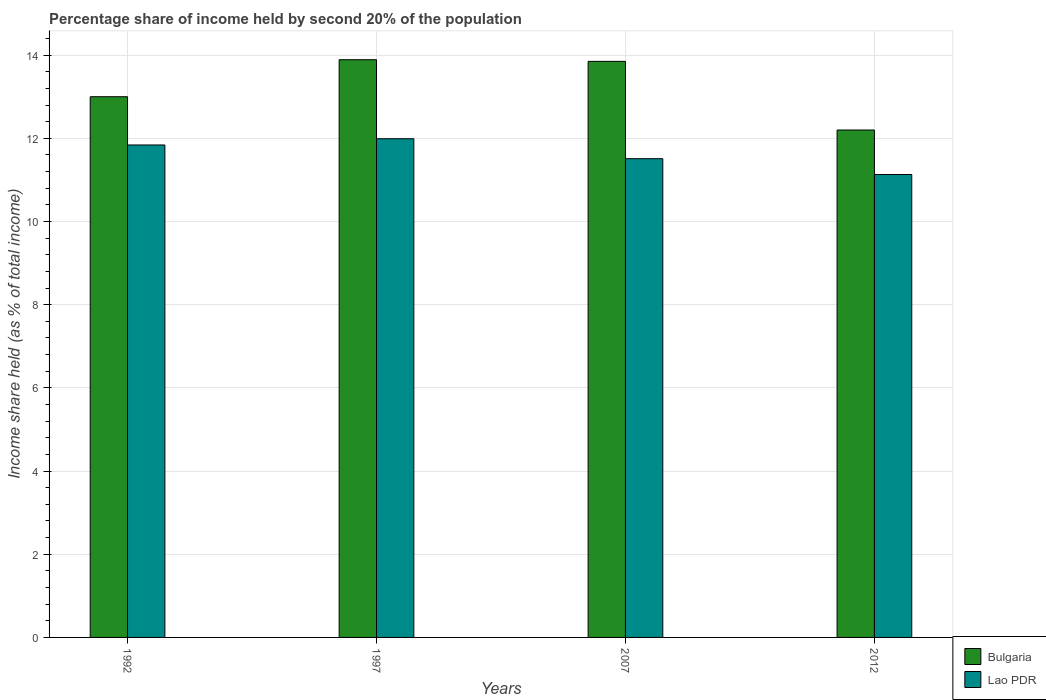How many different coloured bars are there?
Give a very brief answer. 2. Are the number of bars on each tick of the X-axis equal?
Provide a short and direct response. Yes. How many bars are there on the 2nd tick from the left?
Ensure brevity in your answer.  2. How many bars are there on the 2nd tick from the right?
Provide a short and direct response. 2. In how many cases, is the number of bars for a given year not equal to the number of legend labels?
Offer a terse response. 0. What is the share of income held by second 20% of the population in Lao PDR in 2012?
Offer a terse response. 11.13. Across all years, what is the maximum share of income held by second 20% of the population in Bulgaria?
Offer a terse response. 13.89. Across all years, what is the minimum share of income held by second 20% of the population in Lao PDR?
Provide a succinct answer. 11.13. In which year was the share of income held by second 20% of the population in Bulgaria maximum?
Give a very brief answer. 1997. In which year was the share of income held by second 20% of the population in Bulgaria minimum?
Provide a succinct answer. 2012. What is the total share of income held by second 20% of the population in Lao PDR in the graph?
Ensure brevity in your answer.  46.47. What is the difference between the share of income held by second 20% of the population in Lao PDR in 1997 and that in 2007?
Offer a terse response. 0.48. What is the difference between the share of income held by second 20% of the population in Lao PDR in 2007 and the share of income held by second 20% of the population in Bulgaria in 2012?
Offer a very short reply. -0.69. What is the average share of income held by second 20% of the population in Bulgaria per year?
Offer a very short reply. 13.23. In the year 1992, what is the difference between the share of income held by second 20% of the population in Bulgaria and share of income held by second 20% of the population in Lao PDR?
Your answer should be very brief. 1.16. In how many years, is the share of income held by second 20% of the population in Bulgaria greater than 4 %?
Your answer should be very brief. 4. What is the ratio of the share of income held by second 20% of the population in Lao PDR in 1997 to that in 2012?
Make the answer very short. 1.08. Is the difference between the share of income held by second 20% of the population in Bulgaria in 1992 and 2007 greater than the difference between the share of income held by second 20% of the population in Lao PDR in 1992 and 2007?
Provide a succinct answer. No. What is the difference between the highest and the second highest share of income held by second 20% of the population in Lao PDR?
Keep it short and to the point. 0.15. What is the difference between the highest and the lowest share of income held by second 20% of the population in Lao PDR?
Provide a succinct answer. 0.86. Is the sum of the share of income held by second 20% of the population in Lao PDR in 1997 and 2012 greater than the maximum share of income held by second 20% of the population in Bulgaria across all years?
Keep it short and to the point. Yes. What does the 2nd bar from the left in 1997 represents?
Your answer should be compact. Lao PDR. What does the 2nd bar from the right in 2007 represents?
Provide a succinct answer. Bulgaria. What is the difference between two consecutive major ticks on the Y-axis?
Offer a terse response. 2. Are the values on the major ticks of Y-axis written in scientific E-notation?
Provide a short and direct response. No. Does the graph contain grids?
Ensure brevity in your answer.  Yes. Where does the legend appear in the graph?
Your answer should be compact. Bottom right. How are the legend labels stacked?
Make the answer very short. Vertical. What is the title of the graph?
Keep it short and to the point. Percentage share of income held by second 20% of the population. What is the label or title of the X-axis?
Your answer should be compact. Years. What is the label or title of the Y-axis?
Ensure brevity in your answer.  Income share held (as % of total income). What is the Income share held (as % of total income) of Lao PDR in 1992?
Offer a terse response. 11.84. What is the Income share held (as % of total income) in Bulgaria in 1997?
Keep it short and to the point. 13.89. What is the Income share held (as % of total income) in Lao PDR in 1997?
Offer a very short reply. 11.99. What is the Income share held (as % of total income) of Bulgaria in 2007?
Provide a succinct answer. 13.85. What is the Income share held (as % of total income) in Lao PDR in 2007?
Offer a very short reply. 11.51. What is the Income share held (as % of total income) of Bulgaria in 2012?
Your response must be concise. 12.2. What is the Income share held (as % of total income) in Lao PDR in 2012?
Offer a terse response. 11.13. Across all years, what is the maximum Income share held (as % of total income) in Bulgaria?
Offer a terse response. 13.89. Across all years, what is the maximum Income share held (as % of total income) in Lao PDR?
Ensure brevity in your answer.  11.99. Across all years, what is the minimum Income share held (as % of total income) of Lao PDR?
Ensure brevity in your answer.  11.13. What is the total Income share held (as % of total income) of Bulgaria in the graph?
Make the answer very short. 52.94. What is the total Income share held (as % of total income) of Lao PDR in the graph?
Offer a terse response. 46.47. What is the difference between the Income share held (as % of total income) of Bulgaria in 1992 and that in 1997?
Keep it short and to the point. -0.89. What is the difference between the Income share held (as % of total income) in Bulgaria in 1992 and that in 2007?
Your answer should be very brief. -0.85. What is the difference between the Income share held (as % of total income) of Lao PDR in 1992 and that in 2007?
Provide a succinct answer. 0.33. What is the difference between the Income share held (as % of total income) of Lao PDR in 1992 and that in 2012?
Give a very brief answer. 0.71. What is the difference between the Income share held (as % of total income) in Bulgaria in 1997 and that in 2007?
Ensure brevity in your answer.  0.04. What is the difference between the Income share held (as % of total income) in Lao PDR in 1997 and that in 2007?
Your answer should be very brief. 0.48. What is the difference between the Income share held (as % of total income) of Bulgaria in 1997 and that in 2012?
Your answer should be compact. 1.69. What is the difference between the Income share held (as % of total income) of Lao PDR in 1997 and that in 2012?
Your answer should be compact. 0.86. What is the difference between the Income share held (as % of total income) in Bulgaria in 2007 and that in 2012?
Your answer should be very brief. 1.65. What is the difference between the Income share held (as % of total income) in Lao PDR in 2007 and that in 2012?
Offer a terse response. 0.38. What is the difference between the Income share held (as % of total income) in Bulgaria in 1992 and the Income share held (as % of total income) in Lao PDR in 2007?
Your answer should be very brief. 1.49. What is the difference between the Income share held (as % of total income) in Bulgaria in 1992 and the Income share held (as % of total income) in Lao PDR in 2012?
Provide a short and direct response. 1.87. What is the difference between the Income share held (as % of total income) in Bulgaria in 1997 and the Income share held (as % of total income) in Lao PDR in 2007?
Your answer should be compact. 2.38. What is the difference between the Income share held (as % of total income) in Bulgaria in 1997 and the Income share held (as % of total income) in Lao PDR in 2012?
Make the answer very short. 2.76. What is the difference between the Income share held (as % of total income) in Bulgaria in 2007 and the Income share held (as % of total income) in Lao PDR in 2012?
Provide a succinct answer. 2.72. What is the average Income share held (as % of total income) of Bulgaria per year?
Your answer should be very brief. 13.23. What is the average Income share held (as % of total income) of Lao PDR per year?
Provide a short and direct response. 11.62. In the year 1992, what is the difference between the Income share held (as % of total income) in Bulgaria and Income share held (as % of total income) in Lao PDR?
Offer a very short reply. 1.16. In the year 1997, what is the difference between the Income share held (as % of total income) of Bulgaria and Income share held (as % of total income) of Lao PDR?
Give a very brief answer. 1.9. In the year 2007, what is the difference between the Income share held (as % of total income) in Bulgaria and Income share held (as % of total income) in Lao PDR?
Your response must be concise. 2.34. In the year 2012, what is the difference between the Income share held (as % of total income) in Bulgaria and Income share held (as % of total income) in Lao PDR?
Give a very brief answer. 1.07. What is the ratio of the Income share held (as % of total income) of Bulgaria in 1992 to that in 1997?
Provide a short and direct response. 0.94. What is the ratio of the Income share held (as % of total income) of Lao PDR in 1992 to that in 1997?
Ensure brevity in your answer.  0.99. What is the ratio of the Income share held (as % of total income) of Bulgaria in 1992 to that in 2007?
Provide a succinct answer. 0.94. What is the ratio of the Income share held (as % of total income) of Lao PDR in 1992 to that in 2007?
Your answer should be compact. 1.03. What is the ratio of the Income share held (as % of total income) of Bulgaria in 1992 to that in 2012?
Ensure brevity in your answer.  1.07. What is the ratio of the Income share held (as % of total income) of Lao PDR in 1992 to that in 2012?
Provide a succinct answer. 1.06. What is the ratio of the Income share held (as % of total income) in Lao PDR in 1997 to that in 2007?
Offer a terse response. 1.04. What is the ratio of the Income share held (as % of total income) in Bulgaria in 1997 to that in 2012?
Ensure brevity in your answer.  1.14. What is the ratio of the Income share held (as % of total income) in Lao PDR in 1997 to that in 2012?
Provide a succinct answer. 1.08. What is the ratio of the Income share held (as % of total income) of Bulgaria in 2007 to that in 2012?
Offer a terse response. 1.14. What is the ratio of the Income share held (as % of total income) in Lao PDR in 2007 to that in 2012?
Provide a succinct answer. 1.03. What is the difference between the highest and the lowest Income share held (as % of total income) of Bulgaria?
Provide a succinct answer. 1.69. What is the difference between the highest and the lowest Income share held (as % of total income) of Lao PDR?
Offer a very short reply. 0.86. 